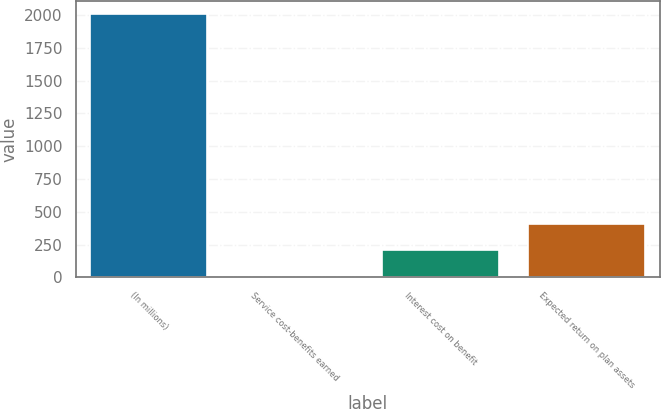<chart> <loc_0><loc_0><loc_500><loc_500><bar_chart><fcel>(In millions)<fcel>Service cost-benefits earned<fcel>Interest cost on benefit<fcel>Expected return on plan assets<nl><fcel>2007<fcel>6<fcel>206.1<fcel>406.2<nl></chart> 